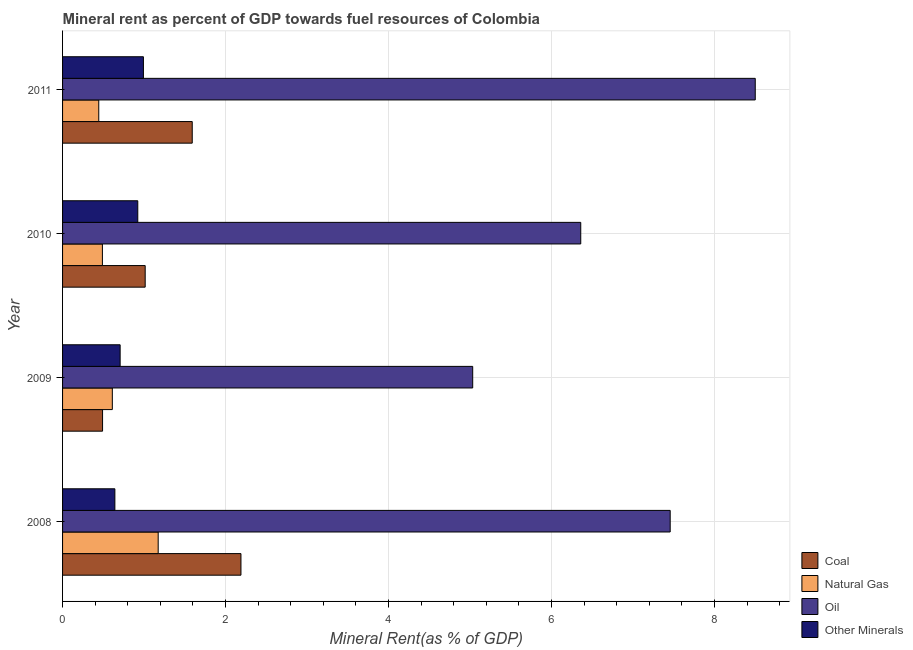How many different coloured bars are there?
Give a very brief answer. 4. How many bars are there on the 4th tick from the top?
Provide a short and direct response. 4. What is the natural gas rent in 2011?
Your answer should be very brief. 0.44. Across all years, what is the maximum oil rent?
Offer a very short reply. 8.5. Across all years, what is the minimum oil rent?
Provide a succinct answer. 5.03. In which year was the  rent of other minerals minimum?
Your answer should be compact. 2008. What is the total natural gas rent in the graph?
Your answer should be compact. 2.72. What is the difference between the natural gas rent in 2009 and that in 2011?
Provide a succinct answer. 0.17. What is the difference between the oil rent in 2010 and the coal rent in 2011?
Your answer should be very brief. 4.77. What is the average  rent of other minerals per year?
Your response must be concise. 0.82. In the year 2009, what is the difference between the natural gas rent and coal rent?
Offer a terse response. 0.12. In how many years, is the  rent of other minerals greater than 2 %?
Your answer should be compact. 0. What is the ratio of the  rent of other minerals in 2008 to that in 2010?
Offer a very short reply. 0.69. Is the oil rent in 2010 less than that in 2011?
Ensure brevity in your answer.  Yes. Is the difference between the  rent of other minerals in 2008 and 2011 greater than the difference between the coal rent in 2008 and 2011?
Make the answer very short. No. What is the difference between the highest and the second highest natural gas rent?
Your answer should be very brief. 0.56. What is the difference between the highest and the lowest oil rent?
Your response must be concise. 3.47. In how many years, is the coal rent greater than the average coal rent taken over all years?
Your answer should be very brief. 2. What does the 2nd bar from the top in 2008 represents?
Keep it short and to the point. Oil. What does the 3rd bar from the bottom in 2008 represents?
Keep it short and to the point. Oil. How many bars are there?
Provide a succinct answer. 16. What is the difference between two consecutive major ticks on the X-axis?
Offer a terse response. 2. Where does the legend appear in the graph?
Your answer should be very brief. Bottom right. What is the title of the graph?
Your answer should be compact. Mineral rent as percent of GDP towards fuel resources of Colombia. Does "Pre-primary schools" appear as one of the legend labels in the graph?
Provide a short and direct response. No. What is the label or title of the X-axis?
Keep it short and to the point. Mineral Rent(as % of GDP). What is the Mineral Rent(as % of GDP) in Coal in 2008?
Your answer should be compact. 2.19. What is the Mineral Rent(as % of GDP) of Natural Gas in 2008?
Give a very brief answer. 1.17. What is the Mineral Rent(as % of GDP) of Oil in 2008?
Offer a terse response. 7.46. What is the Mineral Rent(as % of GDP) of Other Minerals in 2008?
Give a very brief answer. 0.64. What is the Mineral Rent(as % of GDP) of Coal in 2009?
Your response must be concise. 0.49. What is the Mineral Rent(as % of GDP) of Natural Gas in 2009?
Provide a short and direct response. 0.61. What is the Mineral Rent(as % of GDP) in Oil in 2009?
Your answer should be very brief. 5.03. What is the Mineral Rent(as % of GDP) in Other Minerals in 2009?
Make the answer very short. 0.71. What is the Mineral Rent(as % of GDP) in Coal in 2010?
Your answer should be very brief. 1.01. What is the Mineral Rent(as % of GDP) in Natural Gas in 2010?
Provide a short and direct response. 0.49. What is the Mineral Rent(as % of GDP) in Oil in 2010?
Make the answer very short. 6.36. What is the Mineral Rent(as % of GDP) of Other Minerals in 2010?
Your answer should be compact. 0.92. What is the Mineral Rent(as % of GDP) of Coal in 2011?
Your answer should be compact. 1.59. What is the Mineral Rent(as % of GDP) in Natural Gas in 2011?
Keep it short and to the point. 0.44. What is the Mineral Rent(as % of GDP) of Oil in 2011?
Your answer should be compact. 8.5. What is the Mineral Rent(as % of GDP) in Other Minerals in 2011?
Provide a short and direct response. 0.99. Across all years, what is the maximum Mineral Rent(as % of GDP) in Coal?
Your answer should be very brief. 2.19. Across all years, what is the maximum Mineral Rent(as % of GDP) of Natural Gas?
Your response must be concise. 1.17. Across all years, what is the maximum Mineral Rent(as % of GDP) of Oil?
Your answer should be very brief. 8.5. Across all years, what is the maximum Mineral Rent(as % of GDP) of Other Minerals?
Make the answer very short. 0.99. Across all years, what is the minimum Mineral Rent(as % of GDP) of Coal?
Provide a succinct answer. 0.49. Across all years, what is the minimum Mineral Rent(as % of GDP) in Natural Gas?
Ensure brevity in your answer.  0.44. Across all years, what is the minimum Mineral Rent(as % of GDP) in Oil?
Your answer should be compact. 5.03. Across all years, what is the minimum Mineral Rent(as % of GDP) of Other Minerals?
Keep it short and to the point. 0.64. What is the total Mineral Rent(as % of GDP) of Coal in the graph?
Make the answer very short. 5.28. What is the total Mineral Rent(as % of GDP) of Natural Gas in the graph?
Make the answer very short. 2.72. What is the total Mineral Rent(as % of GDP) of Oil in the graph?
Your response must be concise. 27.34. What is the total Mineral Rent(as % of GDP) in Other Minerals in the graph?
Your answer should be compact. 3.26. What is the difference between the Mineral Rent(as % of GDP) of Coal in 2008 and that in 2009?
Provide a short and direct response. 1.7. What is the difference between the Mineral Rent(as % of GDP) of Natural Gas in 2008 and that in 2009?
Make the answer very short. 0.56. What is the difference between the Mineral Rent(as % of GDP) of Oil in 2008 and that in 2009?
Give a very brief answer. 2.42. What is the difference between the Mineral Rent(as % of GDP) of Other Minerals in 2008 and that in 2009?
Your response must be concise. -0.06. What is the difference between the Mineral Rent(as % of GDP) of Coal in 2008 and that in 2010?
Keep it short and to the point. 1.18. What is the difference between the Mineral Rent(as % of GDP) of Natural Gas in 2008 and that in 2010?
Your answer should be compact. 0.68. What is the difference between the Mineral Rent(as % of GDP) in Oil in 2008 and that in 2010?
Your response must be concise. 1.1. What is the difference between the Mineral Rent(as % of GDP) of Other Minerals in 2008 and that in 2010?
Give a very brief answer. -0.28. What is the difference between the Mineral Rent(as % of GDP) in Coal in 2008 and that in 2011?
Keep it short and to the point. 0.6. What is the difference between the Mineral Rent(as % of GDP) in Natural Gas in 2008 and that in 2011?
Offer a very short reply. 0.73. What is the difference between the Mineral Rent(as % of GDP) of Oil in 2008 and that in 2011?
Offer a very short reply. -1.04. What is the difference between the Mineral Rent(as % of GDP) of Other Minerals in 2008 and that in 2011?
Give a very brief answer. -0.35. What is the difference between the Mineral Rent(as % of GDP) of Coal in 2009 and that in 2010?
Give a very brief answer. -0.52. What is the difference between the Mineral Rent(as % of GDP) of Natural Gas in 2009 and that in 2010?
Give a very brief answer. 0.12. What is the difference between the Mineral Rent(as % of GDP) in Oil in 2009 and that in 2010?
Give a very brief answer. -1.33. What is the difference between the Mineral Rent(as % of GDP) in Other Minerals in 2009 and that in 2010?
Give a very brief answer. -0.22. What is the difference between the Mineral Rent(as % of GDP) of Coal in 2009 and that in 2011?
Offer a terse response. -1.1. What is the difference between the Mineral Rent(as % of GDP) in Natural Gas in 2009 and that in 2011?
Provide a succinct answer. 0.17. What is the difference between the Mineral Rent(as % of GDP) in Oil in 2009 and that in 2011?
Offer a very short reply. -3.47. What is the difference between the Mineral Rent(as % of GDP) of Other Minerals in 2009 and that in 2011?
Offer a very short reply. -0.29. What is the difference between the Mineral Rent(as % of GDP) of Coal in 2010 and that in 2011?
Provide a succinct answer. -0.58. What is the difference between the Mineral Rent(as % of GDP) in Natural Gas in 2010 and that in 2011?
Your answer should be very brief. 0.04. What is the difference between the Mineral Rent(as % of GDP) of Oil in 2010 and that in 2011?
Offer a terse response. -2.14. What is the difference between the Mineral Rent(as % of GDP) of Other Minerals in 2010 and that in 2011?
Ensure brevity in your answer.  -0.07. What is the difference between the Mineral Rent(as % of GDP) in Coal in 2008 and the Mineral Rent(as % of GDP) in Natural Gas in 2009?
Provide a succinct answer. 1.58. What is the difference between the Mineral Rent(as % of GDP) of Coal in 2008 and the Mineral Rent(as % of GDP) of Oil in 2009?
Offer a very short reply. -2.84. What is the difference between the Mineral Rent(as % of GDP) of Coal in 2008 and the Mineral Rent(as % of GDP) of Other Minerals in 2009?
Your answer should be very brief. 1.48. What is the difference between the Mineral Rent(as % of GDP) of Natural Gas in 2008 and the Mineral Rent(as % of GDP) of Oil in 2009?
Provide a succinct answer. -3.86. What is the difference between the Mineral Rent(as % of GDP) of Natural Gas in 2008 and the Mineral Rent(as % of GDP) of Other Minerals in 2009?
Make the answer very short. 0.47. What is the difference between the Mineral Rent(as % of GDP) in Oil in 2008 and the Mineral Rent(as % of GDP) in Other Minerals in 2009?
Provide a short and direct response. 6.75. What is the difference between the Mineral Rent(as % of GDP) of Coal in 2008 and the Mineral Rent(as % of GDP) of Natural Gas in 2010?
Ensure brevity in your answer.  1.7. What is the difference between the Mineral Rent(as % of GDP) in Coal in 2008 and the Mineral Rent(as % of GDP) in Oil in 2010?
Offer a terse response. -4.17. What is the difference between the Mineral Rent(as % of GDP) in Coal in 2008 and the Mineral Rent(as % of GDP) in Other Minerals in 2010?
Make the answer very short. 1.27. What is the difference between the Mineral Rent(as % of GDP) in Natural Gas in 2008 and the Mineral Rent(as % of GDP) in Oil in 2010?
Offer a terse response. -5.18. What is the difference between the Mineral Rent(as % of GDP) in Natural Gas in 2008 and the Mineral Rent(as % of GDP) in Other Minerals in 2010?
Give a very brief answer. 0.25. What is the difference between the Mineral Rent(as % of GDP) of Oil in 2008 and the Mineral Rent(as % of GDP) of Other Minerals in 2010?
Your answer should be very brief. 6.53. What is the difference between the Mineral Rent(as % of GDP) in Coal in 2008 and the Mineral Rent(as % of GDP) in Natural Gas in 2011?
Ensure brevity in your answer.  1.74. What is the difference between the Mineral Rent(as % of GDP) in Coal in 2008 and the Mineral Rent(as % of GDP) in Oil in 2011?
Your response must be concise. -6.31. What is the difference between the Mineral Rent(as % of GDP) of Coal in 2008 and the Mineral Rent(as % of GDP) of Other Minerals in 2011?
Give a very brief answer. 1.2. What is the difference between the Mineral Rent(as % of GDP) in Natural Gas in 2008 and the Mineral Rent(as % of GDP) in Oil in 2011?
Your response must be concise. -7.33. What is the difference between the Mineral Rent(as % of GDP) of Natural Gas in 2008 and the Mineral Rent(as % of GDP) of Other Minerals in 2011?
Give a very brief answer. 0.18. What is the difference between the Mineral Rent(as % of GDP) in Oil in 2008 and the Mineral Rent(as % of GDP) in Other Minerals in 2011?
Give a very brief answer. 6.46. What is the difference between the Mineral Rent(as % of GDP) of Coal in 2009 and the Mineral Rent(as % of GDP) of Natural Gas in 2010?
Your response must be concise. 0. What is the difference between the Mineral Rent(as % of GDP) of Coal in 2009 and the Mineral Rent(as % of GDP) of Oil in 2010?
Your answer should be compact. -5.87. What is the difference between the Mineral Rent(as % of GDP) in Coal in 2009 and the Mineral Rent(as % of GDP) in Other Minerals in 2010?
Your answer should be compact. -0.43. What is the difference between the Mineral Rent(as % of GDP) of Natural Gas in 2009 and the Mineral Rent(as % of GDP) of Oil in 2010?
Offer a very short reply. -5.75. What is the difference between the Mineral Rent(as % of GDP) of Natural Gas in 2009 and the Mineral Rent(as % of GDP) of Other Minerals in 2010?
Provide a succinct answer. -0.31. What is the difference between the Mineral Rent(as % of GDP) of Oil in 2009 and the Mineral Rent(as % of GDP) of Other Minerals in 2010?
Ensure brevity in your answer.  4.11. What is the difference between the Mineral Rent(as % of GDP) of Coal in 2009 and the Mineral Rent(as % of GDP) of Natural Gas in 2011?
Keep it short and to the point. 0.05. What is the difference between the Mineral Rent(as % of GDP) in Coal in 2009 and the Mineral Rent(as % of GDP) in Oil in 2011?
Provide a short and direct response. -8.01. What is the difference between the Mineral Rent(as % of GDP) in Coal in 2009 and the Mineral Rent(as % of GDP) in Other Minerals in 2011?
Offer a terse response. -0.5. What is the difference between the Mineral Rent(as % of GDP) in Natural Gas in 2009 and the Mineral Rent(as % of GDP) in Oil in 2011?
Make the answer very short. -7.89. What is the difference between the Mineral Rent(as % of GDP) of Natural Gas in 2009 and the Mineral Rent(as % of GDP) of Other Minerals in 2011?
Keep it short and to the point. -0.38. What is the difference between the Mineral Rent(as % of GDP) in Oil in 2009 and the Mineral Rent(as % of GDP) in Other Minerals in 2011?
Keep it short and to the point. 4.04. What is the difference between the Mineral Rent(as % of GDP) in Coal in 2010 and the Mineral Rent(as % of GDP) in Natural Gas in 2011?
Offer a terse response. 0.57. What is the difference between the Mineral Rent(as % of GDP) in Coal in 2010 and the Mineral Rent(as % of GDP) in Oil in 2011?
Make the answer very short. -7.49. What is the difference between the Mineral Rent(as % of GDP) of Coal in 2010 and the Mineral Rent(as % of GDP) of Other Minerals in 2011?
Offer a terse response. 0.02. What is the difference between the Mineral Rent(as % of GDP) of Natural Gas in 2010 and the Mineral Rent(as % of GDP) of Oil in 2011?
Offer a terse response. -8.01. What is the difference between the Mineral Rent(as % of GDP) in Natural Gas in 2010 and the Mineral Rent(as % of GDP) in Other Minerals in 2011?
Your answer should be very brief. -0.5. What is the difference between the Mineral Rent(as % of GDP) in Oil in 2010 and the Mineral Rent(as % of GDP) in Other Minerals in 2011?
Keep it short and to the point. 5.37. What is the average Mineral Rent(as % of GDP) in Coal per year?
Your answer should be very brief. 1.32. What is the average Mineral Rent(as % of GDP) in Natural Gas per year?
Your answer should be compact. 0.68. What is the average Mineral Rent(as % of GDP) in Oil per year?
Your answer should be compact. 6.84. What is the average Mineral Rent(as % of GDP) in Other Minerals per year?
Make the answer very short. 0.82. In the year 2008, what is the difference between the Mineral Rent(as % of GDP) in Coal and Mineral Rent(as % of GDP) in Natural Gas?
Keep it short and to the point. 1.02. In the year 2008, what is the difference between the Mineral Rent(as % of GDP) of Coal and Mineral Rent(as % of GDP) of Oil?
Your answer should be very brief. -5.27. In the year 2008, what is the difference between the Mineral Rent(as % of GDP) in Coal and Mineral Rent(as % of GDP) in Other Minerals?
Your response must be concise. 1.55. In the year 2008, what is the difference between the Mineral Rent(as % of GDP) in Natural Gas and Mineral Rent(as % of GDP) in Oil?
Offer a very short reply. -6.28. In the year 2008, what is the difference between the Mineral Rent(as % of GDP) of Natural Gas and Mineral Rent(as % of GDP) of Other Minerals?
Keep it short and to the point. 0.53. In the year 2008, what is the difference between the Mineral Rent(as % of GDP) in Oil and Mineral Rent(as % of GDP) in Other Minerals?
Your response must be concise. 6.81. In the year 2009, what is the difference between the Mineral Rent(as % of GDP) of Coal and Mineral Rent(as % of GDP) of Natural Gas?
Offer a very short reply. -0.12. In the year 2009, what is the difference between the Mineral Rent(as % of GDP) of Coal and Mineral Rent(as % of GDP) of Oil?
Give a very brief answer. -4.54. In the year 2009, what is the difference between the Mineral Rent(as % of GDP) in Coal and Mineral Rent(as % of GDP) in Other Minerals?
Offer a very short reply. -0.22. In the year 2009, what is the difference between the Mineral Rent(as % of GDP) of Natural Gas and Mineral Rent(as % of GDP) of Oil?
Provide a succinct answer. -4.42. In the year 2009, what is the difference between the Mineral Rent(as % of GDP) in Natural Gas and Mineral Rent(as % of GDP) in Other Minerals?
Your response must be concise. -0.1. In the year 2009, what is the difference between the Mineral Rent(as % of GDP) of Oil and Mineral Rent(as % of GDP) of Other Minerals?
Keep it short and to the point. 4.33. In the year 2010, what is the difference between the Mineral Rent(as % of GDP) of Coal and Mineral Rent(as % of GDP) of Natural Gas?
Your answer should be very brief. 0.52. In the year 2010, what is the difference between the Mineral Rent(as % of GDP) in Coal and Mineral Rent(as % of GDP) in Oil?
Your response must be concise. -5.34. In the year 2010, what is the difference between the Mineral Rent(as % of GDP) of Coal and Mineral Rent(as % of GDP) of Other Minerals?
Keep it short and to the point. 0.09. In the year 2010, what is the difference between the Mineral Rent(as % of GDP) in Natural Gas and Mineral Rent(as % of GDP) in Oil?
Ensure brevity in your answer.  -5.87. In the year 2010, what is the difference between the Mineral Rent(as % of GDP) in Natural Gas and Mineral Rent(as % of GDP) in Other Minerals?
Keep it short and to the point. -0.43. In the year 2010, what is the difference between the Mineral Rent(as % of GDP) of Oil and Mineral Rent(as % of GDP) of Other Minerals?
Make the answer very short. 5.44. In the year 2011, what is the difference between the Mineral Rent(as % of GDP) of Coal and Mineral Rent(as % of GDP) of Natural Gas?
Provide a short and direct response. 1.15. In the year 2011, what is the difference between the Mineral Rent(as % of GDP) of Coal and Mineral Rent(as % of GDP) of Oil?
Keep it short and to the point. -6.91. In the year 2011, what is the difference between the Mineral Rent(as % of GDP) in Coal and Mineral Rent(as % of GDP) in Other Minerals?
Offer a terse response. 0.6. In the year 2011, what is the difference between the Mineral Rent(as % of GDP) of Natural Gas and Mineral Rent(as % of GDP) of Oil?
Your response must be concise. -8.05. In the year 2011, what is the difference between the Mineral Rent(as % of GDP) in Natural Gas and Mineral Rent(as % of GDP) in Other Minerals?
Make the answer very short. -0.55. In the year 2011, what is the difference between the Mineral Rent(as % of GDP) in Oil and Mineral Rent(as % of GDP) in Other Minerals?
Make the answer very short. 7.51. What is the ratio of the Mineral Rent(as % of GDP) of Coal in 2008 to that in 2009?
Provide a short and direct response. 4.46. What is the ratio of the Mineral Rent(as % of GDP) in Natural Gas in 2008 to that in 2009?
Make the answer very short. 1.92. What is the ratio of the Mineral Rent(as % of GDP) in Oil in 2008 to that in 2009?
Provide a succinct answer. 1.48. What is the ratio of the Mineral Rent(as % of GDP) of Other Minerals in 2008 to that in 2009?
Keep it short and to the point. 0.91. What is the ratio of the Mineral Rent(as % of GDP) in Coal in 2008 to that in 2010?
Your answer should be very brief. 2.16. What is the ratio of the Mineral Rent(as % of GDP) of Natural Gas in 2008 to that in 2010?
Offer a very short reply. 2.4. What is the ratio of the Mineral Rent(as % of GDP) of Oil in 2008 to that in 2010?
Offer a very short reply. 1.17. What is the ratio of the Mineral Rent(as % of GDP) of Other Minerals in 2008 to that in 2010?
Give a very brief answer. 0.7. What is the ratio of the Mineral Rent(as % of GDP) in Coal in 2008 to that in 2011?
Provide a succinct answer. 1.38. What is the ratio of the Mineral Rent(as % of GDP) of Natural Gas in 2008 to that in 2011?
Provide a succinct answer. 2.64. What is the ratio of the Mineral Rent(as % of GDP) of Oil in 2008 to that in 2011?
Keep it short and to the point. 0.88. What is the ratio of the Mineral Rent(as % of GDP) in Other Minerals in 2008 to that in 2011?
Offer a terse response. 0.65. What is the ratio of the Mineral Rent(as % of GDP) of Coal in 2009 to that in 2010?
Your answer should be very brief. 0.48. What is the ratio of the Mineral Rent(as % of GDP) in Natural Gas in 2009 to that in 2010?
Your response must be concise. 1.25. What is the ratio of the Mineral Rent(as % of GDP) in Oil in 2009 to that in 2010?
Your answer should be compact. 0.79. What is the ratio of the Mineral Rent(as % of GDP) of Other Minerals in 2009 to that in 2010?
Your response must be concise. 0.77. What is the ratio of the Mineral Rent(as % of GDP) of Coal in 2009 to that in 2011?
Offer a terse response. 0.31. What is the ratio of the Mineral Rent(as % of GDP) of Natural Gas in 2009 to that in 2011?
Your answer should be very brief. 1.37. What is the ratio of the Mineral Rent(as % of GDP) in Oil in 2009 to that in 2011?
Offer a terse response. 0.59. What is the ratio of the Mineral Rent(as % of GDP) in Other Minerals in 2009 to that in 2011?
Keep it short and to the point. 0.71. What is the ratio of the Mineral Rent(as % of GDP) in Coal in 2010 to that in 2011?
Your answer should be very brief. 0.64. What is the ratio of the Mineral Rent(as % of GDP) of Natural Gas in 2010 to that in 2011?
Your answer should be compact. 1.1. What is the ratio of the Mineral Rent(as % of GDP) of Oil in 2010 to that in 2011?
Make the answer very short. 0.75. What is the ratio of the Mineral Rent(as % of GDP) in Other Minerals in 2010 to that in 2011?
Your response must be concise. 0.93. What is the difference between the highest and the second highest Mineral Rent(as % of GDP) of Coal?
Provide a succinct answer. 0.6. What is the difference between the highest and the second highest Mineral Rent(as % of GDP) of Natural Gas?
Your answer should be very brief. 0.56. What is the difference between the highest and the second highest Mineral Rent(as % of GDP) in Oil?
Provide a short and direct response. 1.04. What is the difference between the highest and the second highest Mineral Rent(as % of GDP) of Other Minerals?
Keep it short and to the point. 0.07. What is the difference between the highest and the lowest Mineral Rent(as % of GDP) in Coal?
Your answer should be very brief. 1.7. What is the difference between the highest and the lowest Mineral Rent(as % of GDP) in Natural Gas?
Provide a succinct answer. 0.73. What is the difference between the highest and the lowest Mineral Rent(as % of GDP) of Oil?
Your answer should be compact. 3.47. What is the difference between the highest and the lowest Mineral Rent(as % of GDP) of Other Minerals?
Your response must be concise. 0.35. 